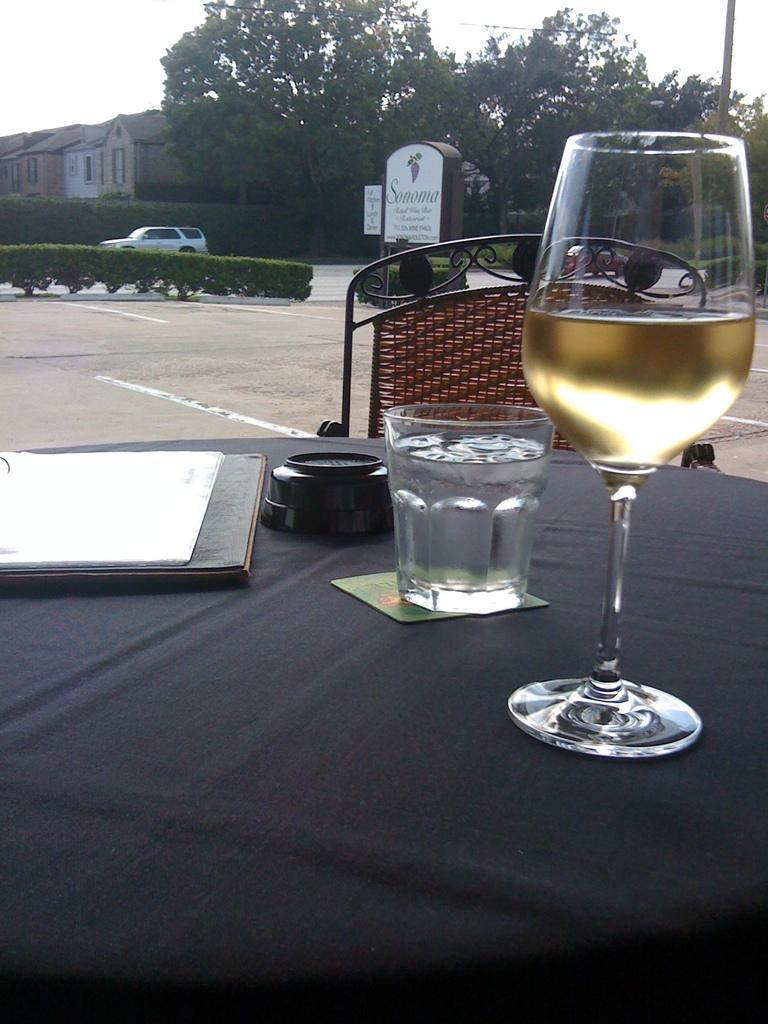What type of glass can be seen in the image? There is a wine glass in the image. Where is the glass located in the image? There is a glass on the table in the image. What type of furniture is present in the image? There is a chair in the image. What type of structures are visible in the background of the image? There are houses visible in the image. What type of vegetation is present in the image? There are trees in the image. What type of vehicle can be seen in the image? There is a car moving on the road in the image. How much does the weight of the wine glass affect the car's movement in the image? The weight of the wine glass does not affect the car's movement in the image, as they are separate objects. Can you hear the grandmother crying in the image? There is no mention of a grandmother or any crying in the image. 